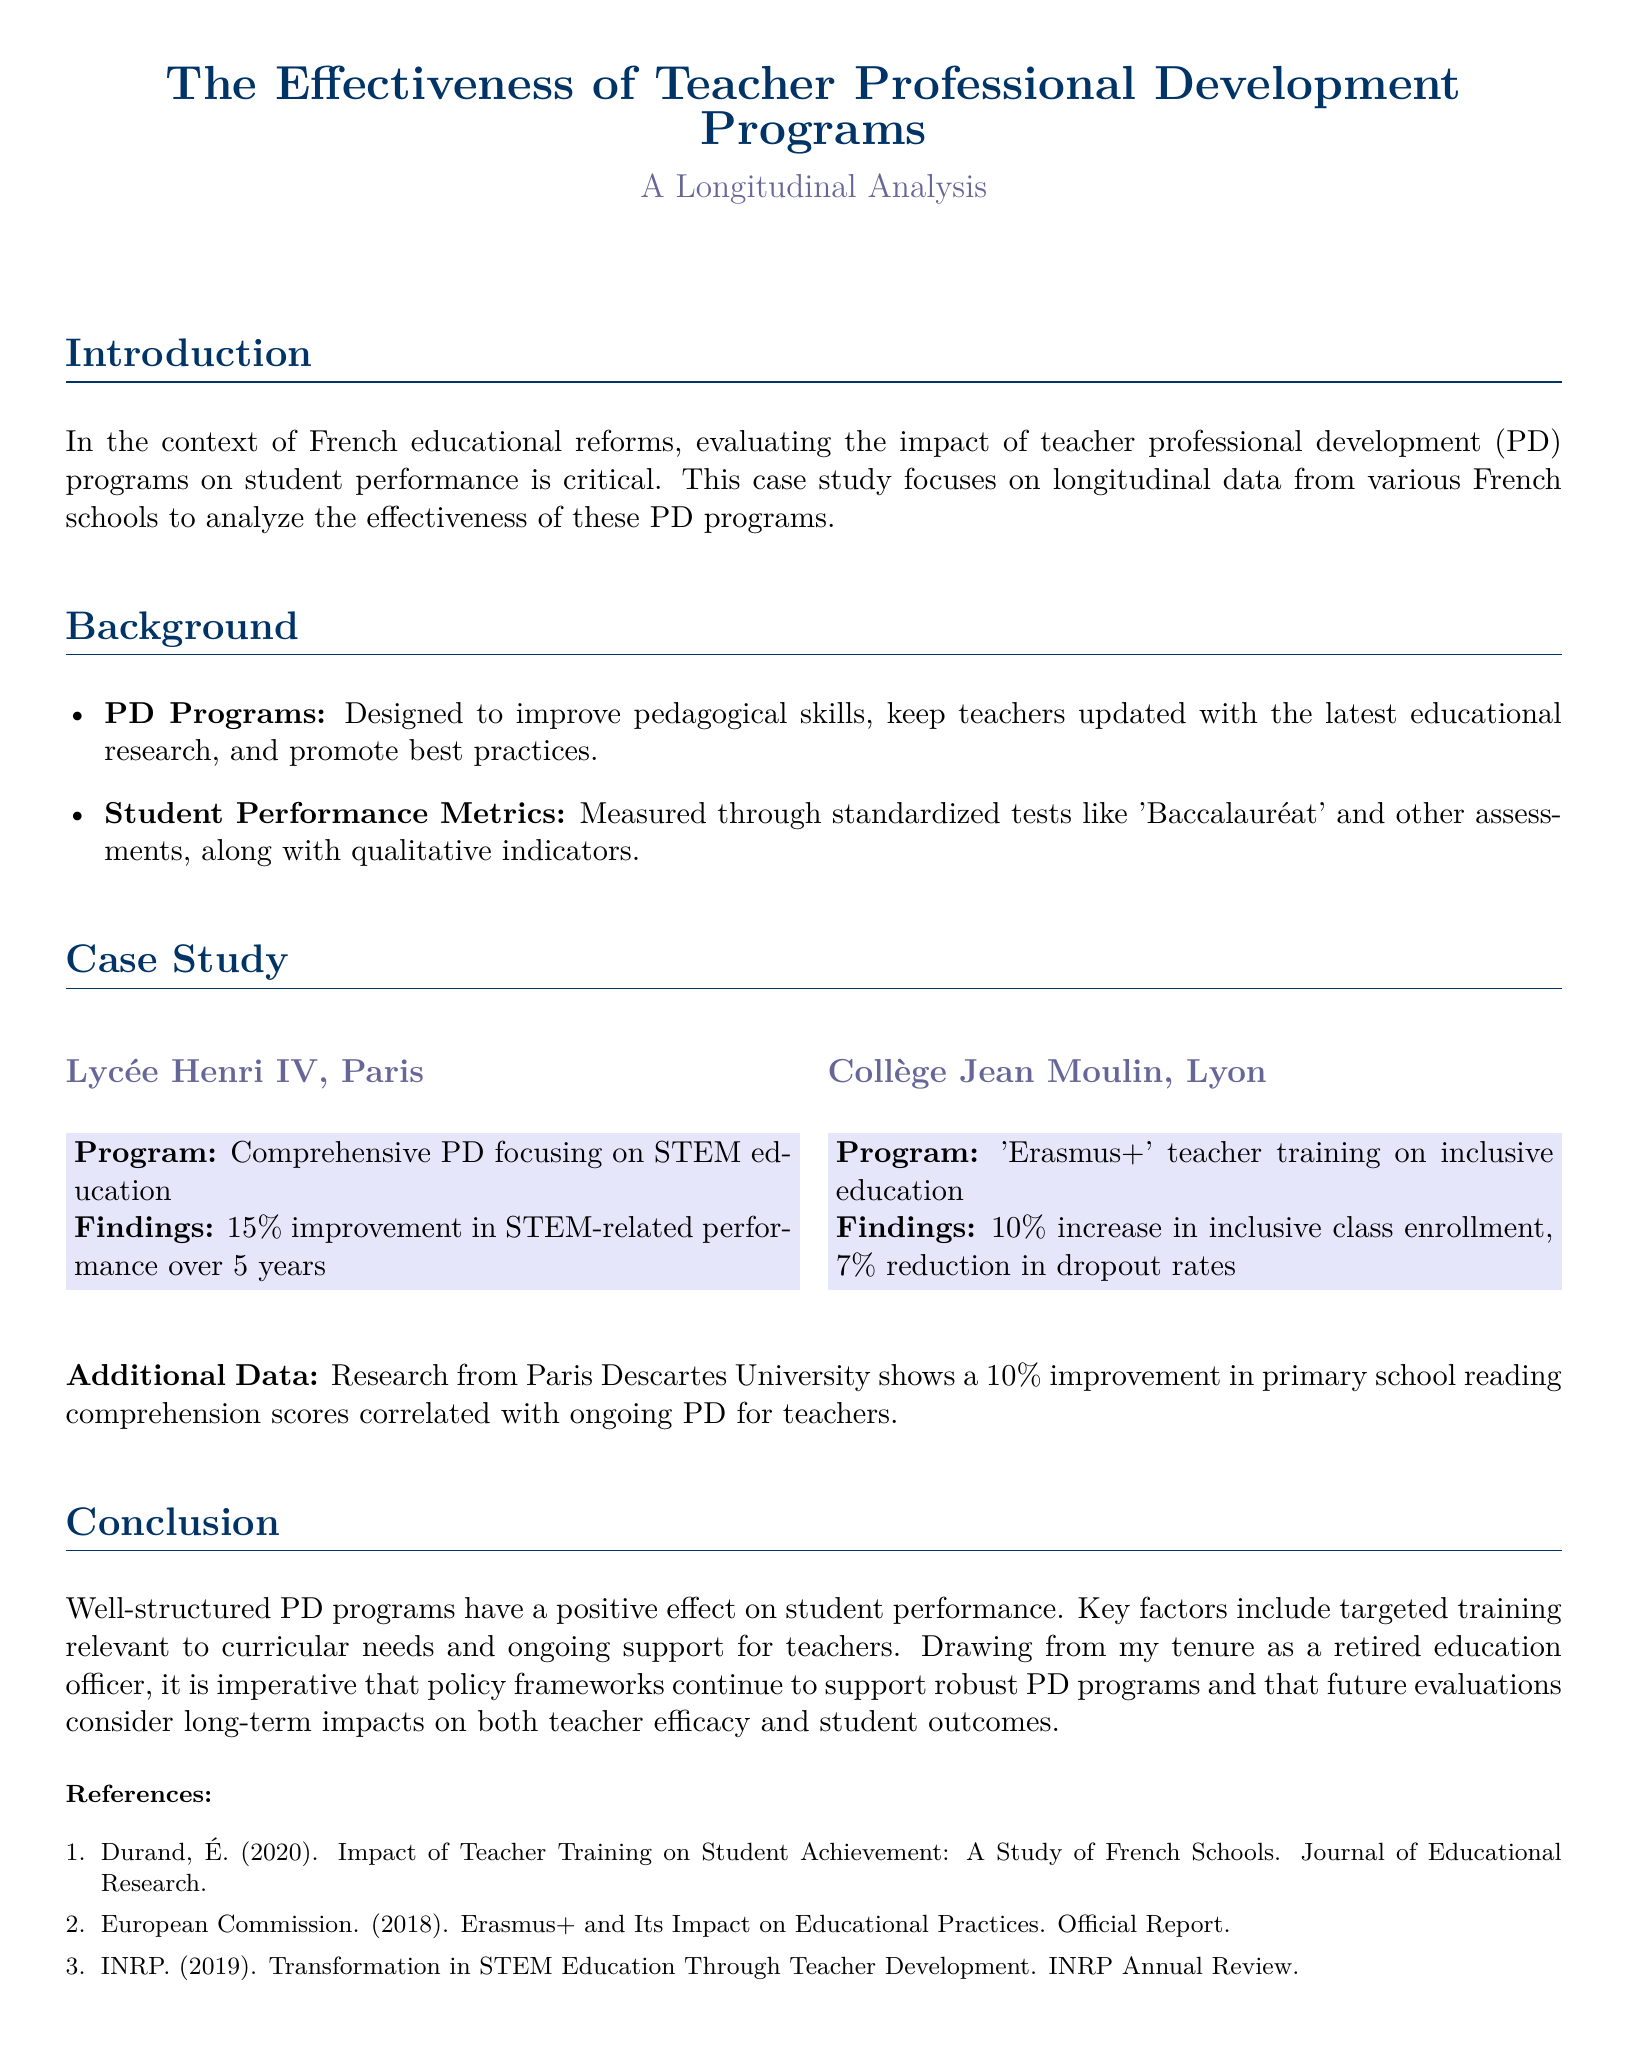What is the primary focus of the case study? The case study aims to analyze the effectiveness of teacher professional development programs on student performance using longitudinal data.
Answer: effectiveness of teacher professional development programs Which school implemented a STEM-focused PD program? The document specifies that Lycée Henri IV in Paris implemented a comprehensive PD focusing on STEM education.
Answer: Lycée Henri IV What percentage improvement in STEM-related performance was reported at Lycée Henri IV? The findings reported a 15% improvement in STEM-related performance over a period of 5 years.
Answer: 15% What was the increase in inclusive class enrollment at Collège Jean Moulin? The case study states that there was a 10% increase in inclusive class enrollment as a result of the PD program.
Answer: 10% How much did dropout rates reduce at Collège Jean Moulin? The document indicates a 7% reduction in dropout rates from Collège Jean Moulin.
Answer: 7% Which university's research showed a correlation between ongoing PD and reading comprehension scores? The research from Paris Descartes University is mentioned in the document as indicating this correlation.
Answer: Paris Descartes University What is a key factor for the effectiveness of PD programs according to the conclusion? The conclusion emphasizes that targeted training relevant to curricular needs is a key factor for the programs' effectiveness.
Answer: targeted training relevant to curricular needs In which year did the European Commission release its report on Erasmus+? The document mentions that the European Commission's report was released in 2018.
Answer: 2018 What is the primary measurement for student performance used in the case study? The document states that student performance is measured through standardized tests like 'Baccalauréat.'
Answer: 'Baccalauréat' 